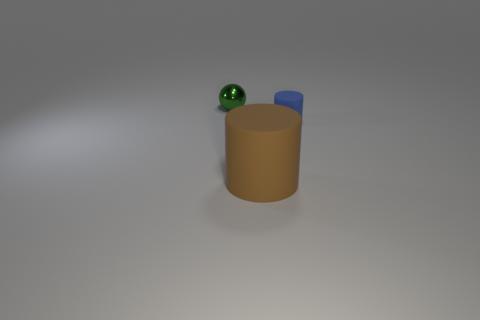Does the cylinder that is on the right side of the brown cylinder have the same color as the large thing?
Make the answer very short. No. What number of brown cylinders are the same size as the brown matte thing?
Provide a short and direct response. 0. Are there any large metal balls of the same color as the small metal sphere?
Ensure brevity in your answer.  No. Is the tiny sphere made of the same material as the big brown thing?
Your answer should be very brief. No. How many other brown objects have the same shape as the big object?
Provide a succinct answer. 0. What is the shape of the big brown thing that is made of the same material as the blue cylinder?
Offer a very short reply. Cylinder. The rubber cylinder that is in front of the rubber thing that is behind the big brown object is what color?
Provide a short and direct response. Brown. Does the small matte thing have the same color as the small metal thing?
Offer a terse response. No. What is the thing in front of the tiny object that is in front of the shiny thing made of?
Provide a succinct answer. Rubber. What material is the big brown thing that is the same shape as the blue rubber thing?
Offer a very short reply. Rubber. 